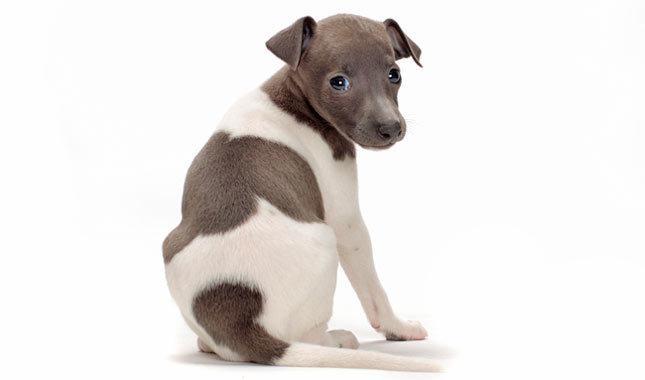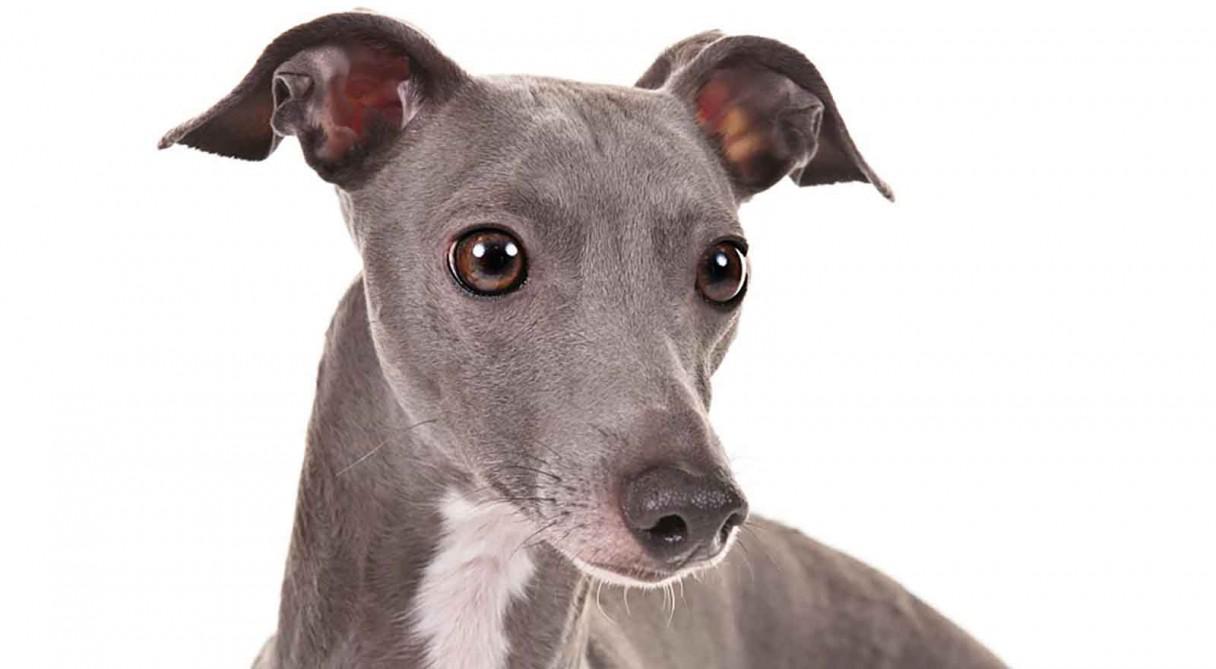The first image is the image on the left, the second image is the image on the right. Given the left and right images, does the statement "At least one of the dogs is wearing some type of material." hold true? Answer yes or no. No. The first image is the image on the left, the second image is the image on the right. Examine the images to the left and right. Is the description "In total, more than one dog is wearing something around its neck." accurate? Answer yes or no. No. 